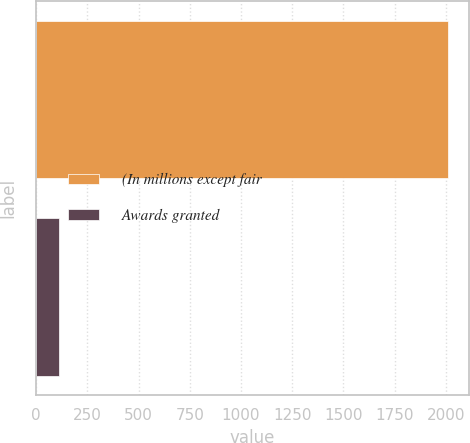Convert chart. <chart><loc_0><loc_0><loc_500><loc_500><bar_chart><fcel>(In millions except fair<fcel>Awards granted<nl><fcel>2012<fcel>110<nl></chart> 